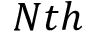<formula> <loc_0><loc_0><loc_500><loc_500>N t h</formula> 